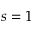Convert formula to latex. <formula><loc_0><loc_0><loc_500><loc_500>s = 1</formula> 